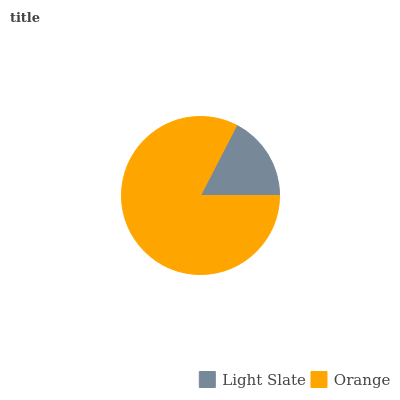Is Light Slate the minimum?
Answer yes or no. Yes. Is Orange the maximum?
Answer yes or no. Yes. Is Orange the minimum?
Answer yes or no. No. Is Orange greater than Light Slate?
Answer yes or no. Yes. Is Light Slate less than Orange?
Answer yes or no. Yes. Is Light Slate greater than Orange?
Answer yes or no. No. Is Orange less than Light Slate?
Answer yes or no. No. Is Orange the high median?
Answer yes or no. Yes. Is Light Slate the low median?
Answer yes or no. Yes. Is Light Slate the high median?
Answer yes or no. No. Is Orange the low median?
Answer yes or no. No. 